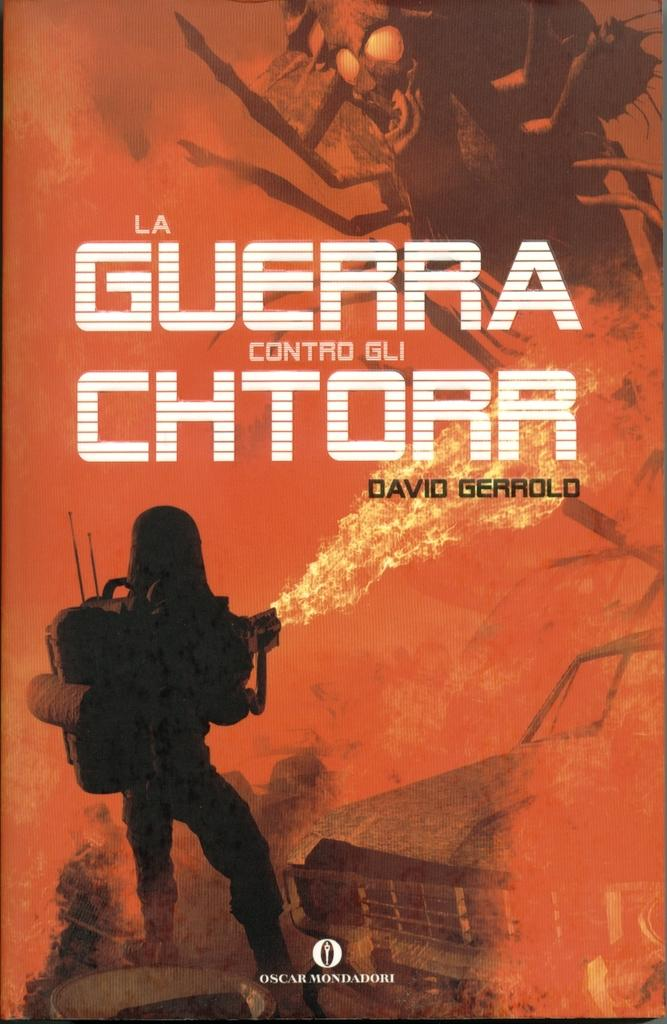<image>
Provide a brief description of the given image. The title guerra chtorr is written on a orange poster with a drawing at the bottom. 